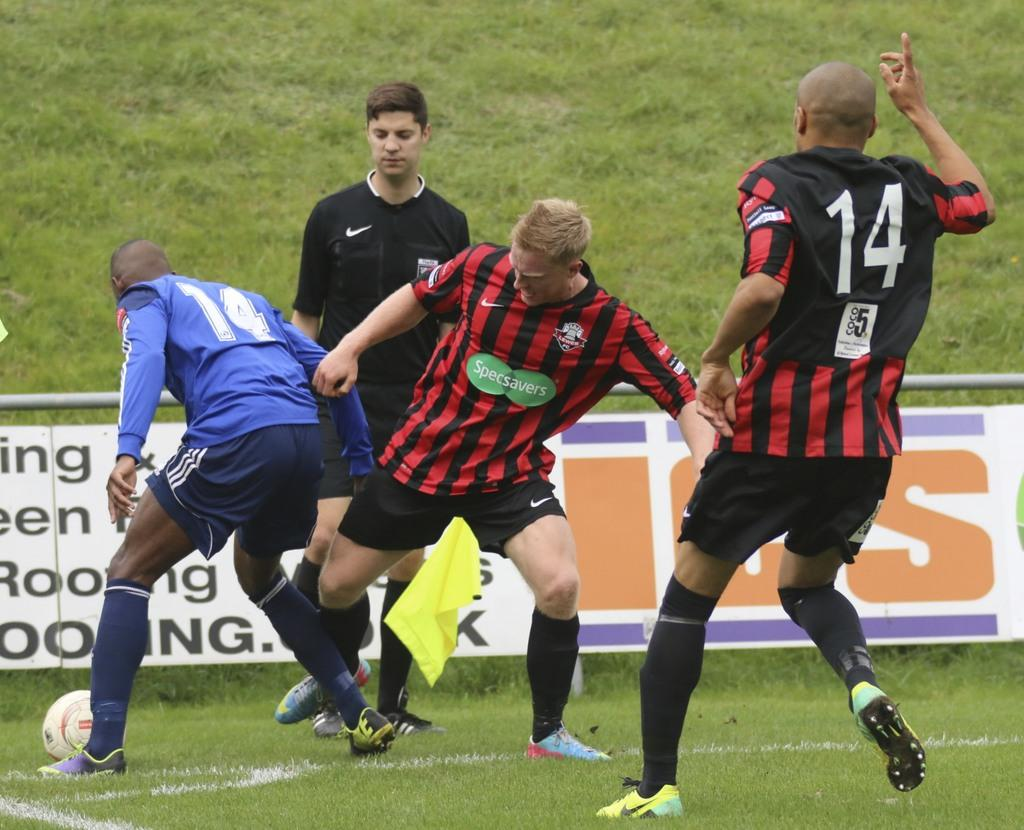Provide a one-sentence caption for the provided image. A player with number 14 holds up his right hand. 